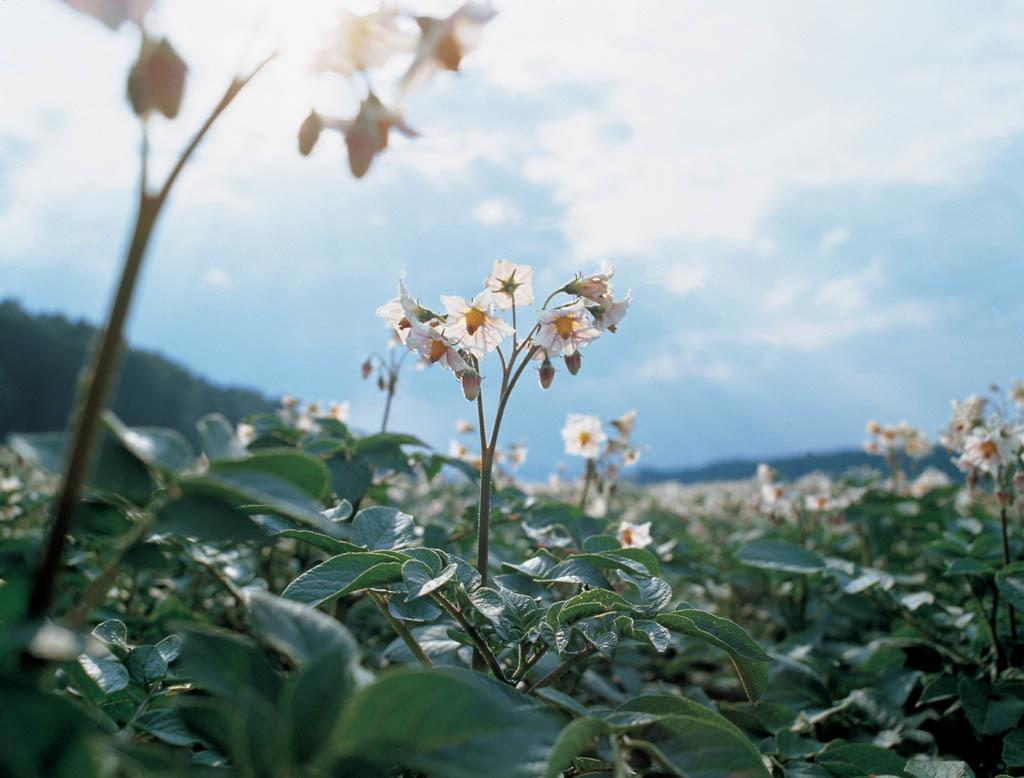What type of plant parts can be seen in the image? There are leaves, stems, flowers, and buds in the image. What is the background of the image like? The background of the image is blurred. What can be seen in the sky in the image? The sky is visible in the image, and clouds are present. Can you see any matches or cheese in the image? No, there are no matches or cheese present in the image. Did the earthquake cause any damage to the plants in the image? There is no mention of an earthquake in the image or the provided facts, so we cannot determine if it caused any damage to the plants. 